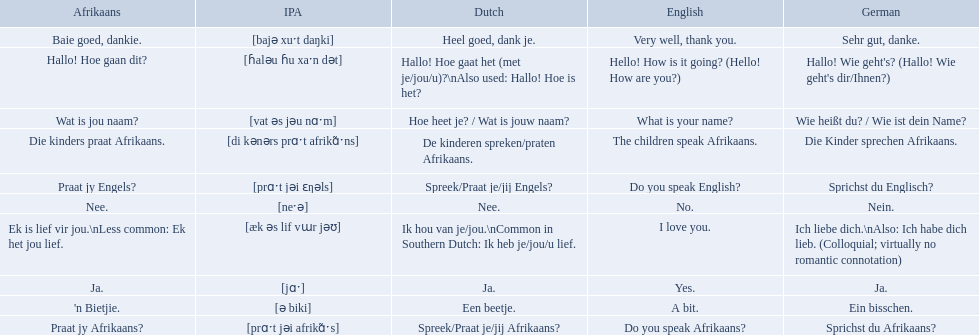What are all of the afrikaans phrases in the list? Hallo! Hoe gaan dit?, Baie goed, dankie., Praat jy Afrikaans?, Praat jy Engels?, Ja., Nee., 'n Bietjie., Wat is jou naam?, Die kinders praat Afrikaans., Ek is lief vir jou.\nLess common: Ek het jou lief. What is the english translation of each phrase? Hello! How is it going? (Hello! How are you?), Very well, thank you., Do you speak Afrikaans?, Do you speak English?, Yes., No., A bit., What is your name?, The children speak Afrikaans., I love you. And which afrikaans phrase translated to do you speak afrikaans? Praat jy Afrikaans?. 